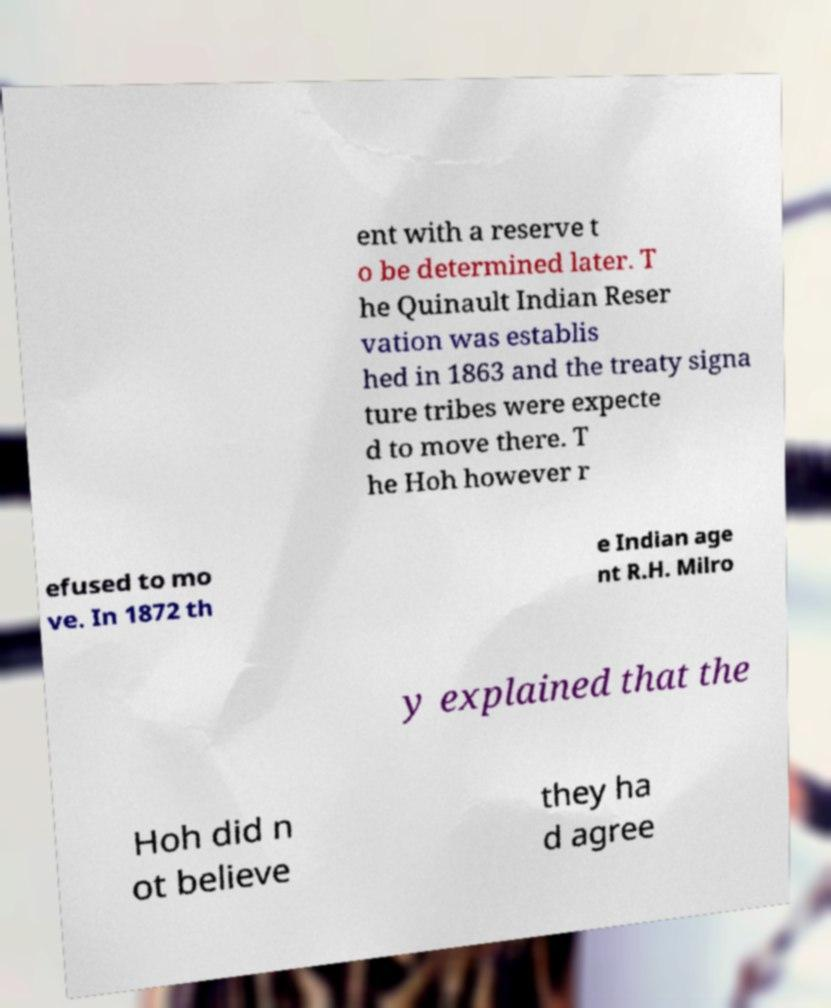What messages or text are displayed in this image? I need them in a readable, typed format. ent with a reserve t o be determined later. T he Quinault Indian Reser vation was establis hed in 1863 and the treaty signa ture tribes were expecte d to move there. T he Hoh however r efused to mo ve. In 1872 th e Indian age nt R.H. Milro y explained that the Hoh did n ot believe they ha d agree 